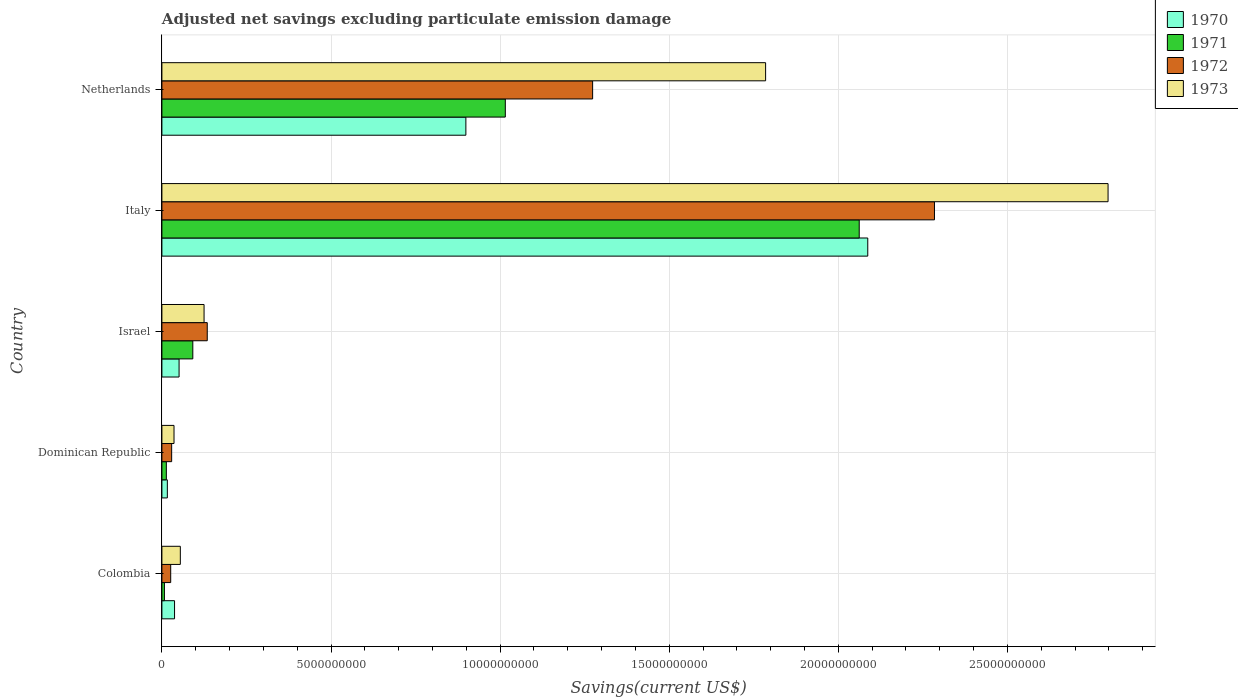How many different coloured bars are there?
Your response must be concise. 4. How many groups of bars are there?
Make the answer very short. 5. Are the number of bars on each tick of the Y-axis equal?
Ensure brevity in your answer.  Yes. How many bars are there on the 1st tick from the bottom?
Provide a short and direct response. 4. What is the label of the 4th group of bars from the top?
Your answer should be compact. Dominican Republic. In how many cases, is the number of bars for a given country not equal to the number of legend labels?
Offer a very short reply. 0. What is the adjusted net savings in 1970 in Dominican Republic?
Provide a succinct answer. 1.61e+08. Across all countries, what is the maximum adjusted net savings in 1971?
Ensure brevity in your answer.  2.06e+1. Across all countries, what is the minimum adjusted net savings in 1971?
Provide a short and direct response. 7.46e+07. In which country was the adjusted net savings in 1973 maximum?
Make the answer very short. Italy. In which country was the adjusted net savings in 1971 minimum?
Provide a succinct answer. Colombia. What is the total adjusted net savings in 1973 in the graph?
Give a very brief answer. 4.80e+1. What is the difference between the adjusted net savings in 1970 in Italy and that in Netherlands?
Make the answer very short. 1.19e+1. What is the difference between the adjusted net savings in 1973 in Italy and the adjusted net savings in 1970 in Colombia?
Offer a terse response. 2.76e+1. What is the average adjusted net savings in 1972 per country?
Offer a terse response. 7.49e+09. What is the difference between the adjusted net savings in 1970 and adjusted net savings in 1972 in Israel?
Your answer should be compact. -8.33e+08. In how many countries, is the adjusted net savings in 1971 greater than 25000000000 US$?
Provide a succinct answer. 0. What is the ratio of the adjusted net savings in 1972 in Israel to that in Italy?
Offer a terse response. 0.06. Is the adjusted net savings in 1972 in Dominican Republic less than that in Italy?
Keep it short and to the point. Yes. What is the difference between the highest and the second highest adjusted net savings in 1973?
Offer a terse response. 1.01e+1. What is the difference between the highest and the lowest adjusted net savings in 1973?
Ensure brevity in your answer.  2.76e+1. In how many countries, is the adjusted net savings in 1973 greater than the average adjusted net savings in 1973 taken over all countries?
Offer a very short reply. 2. Is the sum of the adjusted net savings in 1971 in Colombia and Dominican Republic greater than the maximum adjusted net savings in 1972 across all countries?
Offer a terse response. No. Is it the case that in every country, the sum of the adjusted net savings in 1972 and adjusted net savings in 1973 is greater than the sum of adjusted net savings in 1971 and adjusted net savings in 1970?
Ensure brevity in your answer.  No. What does the 1st bar from the top in Israel represents?
Your answer should be compact. 1973. What does the 4th bar from the bottom in Colombia represents?
Provide a short and direct response. 1973. Are all the bars in the graph horizontal?
Your answer should be very brief. Yes. Does the graph contain grids?
Provide a short and direct response. Yes. What is the title of the graph?
Provide a short and direct response. Adjusted net savings excluding particulate emission damage. What is the label or title of the X-axis?
Provide a succinct answer. Savings(current US$). What is the label or title of the Y-axis?
Ensure brevity in your answer.  Country. What is the Savings(current US$) of 1970 in Colombia?
Your response must be concise. 3.74e+08. What is the Savings(current US$) of 1971 in Colombia?
Offer a terse response. 7.46e+07. What is the Savings(current US$) in 1972 in Colombia?
Give a very brief answer. 2.60e+08. What is the Savings(current US$) of 1973 in Colombia?
Your answer should be very brief. 5.45e+08. What is the Savings(current US$) of 1970 in Dominican Republic?
Offer a terse response. 1.61e+08. What is the Savings(current US$) of 1971 in Dominican Republic?
Provide a succinct answer. 1.32e+08. What is the Savings(current US$) in 1972 in Dominican Republic?
Ensure brevity in your answer.  2.89e+08. What is the Savings(current US$) of 1973 in Dominican Republic?
Offer a very short reply. 3.58e+08. What is the Savings(current US$) of 1970 in Israel?
Offer a terse response. 5.08e+08. What is the Savings(current US$) in 1971 in Israel?
Your answer should be very brief. 9.14e+08. What is the Savings(current US$) of 1972 in Israel?
Your response must be concise. 1.34e+09. What is the Savings(current US$) of 1973 in Israel?
Provide a short and direct response. 1.25e+09. What is the Savings(current US$) in 1970 in Italy?
Your answer should be compact. 2.09e+1. What is the Savings(current US$) of 1971 in Italy?
Provide a short and direct response. 2.06e+1. What is the Savings(current US$) in 1972 in Italy?
Provide a short and direct response. 2.28e+1. What is the Savings(current US$) in 1973 in Italy?
Your answer should be very brief. 2.80e+1. What is the Savings(current US$) in 1970 in Netherlands?
Provide a short and direct response. 8.99e+09. What is the Savings(current US$) in 1971 in Netherlands?
Ensure brevity in your answer.  1.02e+1. What is the Savings(current US$) of 1972 in Netherlands?
Offer a terse response. 1.27e+1. What is the Savings(current US$) of 1973 in Netherlands?
Provide a succinct answer. 1.79e+1. Across all countries, what is the maximum Savings(current US$) of 1970?
Your answer should be compact. 2.09e+1. Across all countries, what is the maximum Savings(current US$) of 1971?
Provide a succinct answer. 2.06e+1. Across all countries, what is the maximum Savings(current US$) of 1972?
Make the answer very short. 2.28e+1. Across all countries, what is the maximum Savings(current US$) of 1973?
Your answer should be compact. 2.80e+1. Across all countries, what is the minimum Savings(current US$) in 1970?
Your answer should be very brief. 1.61e+08. Across all countries, what is the minimum Savings(current US$) of 1971?
Your response must be concise. 7.46e+07. Across all countries, what is the minimum Savings(current US$) in 1972?
Your answer should be very brief. 2.60e+08. Across all countries, what is the minimum Savings(current US$) in 1973?
Provide a short and direct response. 3.58e+08. What is the total Savings(current US$) of 1970 in the graph?
Give a very brief answer. 3.09e+1. What is the total Savings(current US$) of 1971 in the graph?
Provide a short and direct response. 3.19e+1. What is the total Savings(current US$) of 1972 in the graph?
Your answer should be compact. 3.75e+1. What is the total Savings(current US$) in 1973 in the graph?
Your answer should be very brief. 4.80e+1. What is the difference between the Savings(current US$) of 1970 in Colombia and that in Dominican Republic?
Provide a short and direct response. 2.13e+08. What is the difference between the Savings(current US$) in 1971 in Colombia and that in Dominican Republic?
Keep it short and to the point. -5.69e+07. What is the difference between the Savings(current US$) in 1972 in Colombia and that in Dominican Republic?
Your response must be concise. -2.84e+07. What is the difference between the Savings(current US$) in 1973 in Colombia and that in Dominican Republic?
Your answer should be very brief. 1.87e+08. What is the difference between the Savings(current US$) in 1970 in Colombia and that in Israel?
Ensure brevity in your answer.  -1.34e+08. What is the difference between the Savings(current US$) in 1971 in Colombia and that in Israel?
Offer a terse response. -8.40e+08. What is the difference between the Savings(current US$) of 1972 in Colombia and that in Israel?
Your answer should be compact. -1.08e+09. What is the difference between the Savings(current US$) in 1973 in Colombia and that in Israel?
Make the answer very short. -7.02e+08. What is the difference between the Savings(current US$) in 1970 in Colombia and that in Italy?
Your answer should be compact. -2.05e+1. What is the difference between the Savings(current US$) of 1971 in Colombia and that in Italy?
Your answer should be very brief. -2.05e+1. What is the difference between the Savings(current US$) in 1972 in Colombia and that in Italy?
Your response must be concise. -2.26e+1. What is the difference between the Savings(current US$) in 1973 in Colombia and that in Italy?
Offer a very short reply. -2.74e+1. What is the difference between the Savings(current US$) in 1970 in Colombia and that in Netherlands?
Offer a very short reply. -8.61e+09. What is the difference between the Savings(current US$) of 1971 in Colombia and that in Netherlands?
Make the answer very short. -1.01e+1. What is the difference between the Savings(current US$) of 1972 in Colombia and that in Netherlands?
Your answer should be compact. -1.25e+1. What is the difference between the Savings(current US$) of 1973 in Colombia and that in Netherlands?
Make the answer very short. -1.73e+1. What is the difference between the Savings(current US$) in 1970 in Dominican Republic and that in Israel?
Make the answer very short. -3.47e+08. What is the difference between the Savings(current US$) of 1971 in Dominican Republic and that in Israel?
Offer a very short reply. -7.83e+08. What is the difference between the Savings(current US$) in 1972 in Dominican Republic and that in Israel?
Give a very brief answer. -1.05e+09. What is the difference between the Savings(current US$) in 1973 in Dominican Republic and that in Israel?
Your answer should be very brief. -8.89e+08. What is the difference between the Savings(current US$) in 1970 in Dominican Republic and that in Italy?
Your response must be concise. -2.07e+1. What is the difference between the Savings(current US$) in 1971 in Dominican Republic and that in Italy?
Your answer should be compact. -2.05e+1. What is the difference between the Savings(current US$) of 1972 in Dominican Republic and that in Italy?
Offer a very short reply. -2.26e+1. What is the difference between the Savings(current US$) in 1973 in Dominican Republic and that in Italy?
Your response must be concise. -2.76e+1. What is the difference between the Savings(current US$) of 1970 in Dominican Republic and that in Netherlands?
Your answer should be very brief. -8.83e+09. What is the difference between the Savings(current US$) in 1971 in Dominican Republic and that in Netherlands?
Your response must be concise. -1.00e+1. What is the difference between the Savings(current US$) in 1972 in Dominican Republic and that in Netherlands?
Your answer should be compact. -1.24e+1. What is the difference between the Savings(current US$) of 1973 in Dominican Republic and that in Netherlands?
Provide a succinct answer. -1.75e+1. What is the difference between the Savings(current US$) in 1970 in Israel and that in Italy?
Provide a short and direct response. -2.04e+1. What is the difference between the Savings(current US$) in 1971 in Israel and that in Italy?
Your answer should be compact. -1.97e+1. What is the difference between the Savings(current US$) in 1972 in Israel and that in Italy?
Ensure brevity in your answer.  -2.15e+1. What is the difference between the Savings(current US$) of 1973 in Israel and that in Italy?
Your response must be concise. -2.67e+1. What is the difference between the Savings(current US$) of 1970 in Israel and that in Netherlands?
Give a very brief answer. -8.48e+09. What is the difference between the Savings(current US$) in 1971 in Israel and that in Netherlands?
Your response must be concise. -9.24e+09. What is the difference between the Savings(current US$) in 1972 in Israel and that in Netherlands?
Make the answer very short. -1.14e+1. What is the difference between the Savings(current US$) of 1973 in Israel and that in Netherlands?
Your response must be concise. -1.66e+1. What is the difference between the Savings(current US$) of 1970 in Italy and that in Netherlands?
Your answer should be compact. 1.19e+1. What is the difference between the Savings(current US$) of 1971 in Italy and that in Netherlands?
Your answer should be very brief. 1.05e+1. What is the difference between the Savings(current US$) of 1972 in Italy and that in Netherlands?
Your answer should be very brief. 1.01e+1. What is the difference between the Savings(current US$) of 1973 in Italy and that in Netherlands?
Ensure brevity in your answer.  1.01e+1. What is the difference between the Savings(current US$) of 1970 in Colombia and the Savings(current US$) of 1971 in Dominican Republic?
Your response must be concise. 2.42e+08. What is the difference between the Savings(current US$) of 1970 in Colombia and the Savings(current US$) of 1972 in Dominican Republic?
Provide a short and direct response. 8.52e+07. What is the difference between the Savings(current US$) in 1970 in Colombia and the Savings(current US$) in 1973 in Dominican Republic?
Provide a short and direct response. 1.57e+07. What is the difference between the Savings(current US$) of 1971 in Colombia and the Savings(current US$) of 1972 in Dominican Republic?
Your response must be concise. -2.14e+08. What is the difference between the Savings(current US$) in 1971 in Colombia and the Savings(current US$) in 1973 in Dominican Republic?
Your response must be concise. -2.84e+08. What is the difference between the Savings(current US$) in 1972 in Colombia and the Savings(current US$) in 1973 in Dominican Republic?
Provide a succinct answer. -9.79e+07. What is the difference between the Savings(current US$) of 1970 in Colombia and the Savings(current US$) of 1971 in Israel?
Ensure brevity in your answer.  -5.40e+08. What is the difference between the Savings(current US$) of 1970 in Colombia and the Savings(current US$) of 1972 in Israel?
Offer a terse response. -9.67e+08. What is the difference between the Savings(current US$) of 1970 in Colombia and the Savings(current US$) of 1973 in Israel?
Your answer should be very brief. -8.73e+08. What is the difference between the Savings(current US$) of 1971 in Colombia and the Savings(current US$) of 1972 in Israel?
Your answer should be compact. -1.27e+09. What is the difference between the Savings(current US$) in 1971 in Colombia and the Savings(current US$) in 1973 in Israel?
Keep it short and to the point. -1.17e+09. What is the difference between the Savings(current US$) of 1972 in Colombia and the Savings(current US$) of 1973 in Israel?
Your response must be concise. -9.87e+08. What is the difference between the Savings(current US$) in 1970 in Colombia and the Savings(current US$) in 1971 in Italy?
Offer a terse response. -2.02e+1. What is the difference between the Savings(current US$) of 1970 in Colombia and the Savings(current US$) of 1972 in Italy?
Provide a succinct answer. -2.25e+1. What is the difference between the Savings(current US$) of 1970 in Colombia and the Savings(current US$) of 1973 in Italy?
Make the answer very short. -2.76e+1. What is the difference between the Savings(current US$) of 1971 in Colombia and the Savings(current US$) of 1972 in Italy?
Your response must be concise. -2.28e+1. What is the difference between the Savings(current US$) in 1971 in Colombia and the Savings(current US$) in 1973 in Italy?
Make the answer very short. -2.79e+1. What is the difference between the Savings(current US$) in 1972 in Colombia and the Savings(current US$) in 1973 in Italy?
Offer a very short reply. -2.77e+1. What is the difference between the Savings(current US$) in 1970 in Colombia and the Savings(current US$) in 1971 in Netherlands?
Offer a terse response. -9.78e+09. What is the difference between the Savings(current US$) in 1970 in Colombia and the Savings(current US$) in 1972 in Netherlands?
Make the answer very short. -1.24e+1. What is the difference between the Savings(current US$) in 1970 in Colombia and the Savings(current US$) in 1973 in Netherlands?
Offer a terse response. -1.75e+1. What is the difference between the Savings(current US$) in 1971 in Colombia and the Savings(current US$) in 1972 in Netherlands?
Offer a terse response. -1.27e+1. What is the difference between the Savings(current US$) of 1971 in Colombia and the Savings(current US$) of 1973 in Netherlands?
Your response must be concise. -1.78e+1. What is the difference between the Savings(current US$) in 1972 in Colombia and the Savings(current US$) in 1973 in Netherlands?
Your answer should be very brief. -1.76e+1. What is the difference between the Savings(current US$) of 1970 in Dominican Republic and the Savings(current US$) of 1971 in Israel?
Your response must be concise. -7.53e+08. What is the difference between the Savings(current US$) of 1970 in Dominican Republic and the Savings(current US$) of 1972 in Israel?
Your answer should be very brief. -1.18e+09. What is the difference between the Savings(current US$) in 1970 in Dominican Republic and the Savings(current US$) in 1973 in Israel?
Your answer should be very brief. -1.09e+09. What is the difference between the Savings(current US$) of 1971 in Dominican Republic and the Savings(current US$) of 1972 in Israel?
Provide a short and direct response. -1.21e+09. What is the difference between the Savings(current US$) of 1971 in Dominican Republic and the Savings(current US$) of 1973 in Israel?
Give a very brief answer. -1.12e+09. What is the difference between the Savings(current US$) in 1972 in Dominican Republic and the Savings(current US$) in 1973 in Israel?
Your answer should be compact. -9.58e+08. What is the difference between the Savings(current US$) of 1970 in Dominican Republic and the Savings(current US$) of 1971 in Italy?
Provide a short and direct response. -2.05e+1. What is the difference between the Savings(current US$) in 1970 in Dominican Republic and the Savings(current US$) in 1972 in Italy?
Your answer should be very brief. -2.27e+1. What is the difference between the Savings(current US$) in 1970 in Dominican Republic and the Savings(current US$) in 1973 in Italy?
Your answer should be very brief. -2.78e+1. What is the difference between the Savings(current US$) in 1971 in Dominican Republic and the Savings(current US$) in 1972 in Italy?
Your answer should be compact. -2.27e+1. What is the difference between the Savings(current US$) of 1971 in Dominican Republic and the Savings(current US$) of 1973 in Italy?
Keep it short and to the point. -2.78e+1. What is the difference between the Savings(current US$) in 1972 in Dominican Republic and the Savings(current US$) in 1973 in Italy?
Provide a short and direct response. -2.77e+1. What is the difference between the Savings(current US$) of 1970 in Dominican Republic and the Savings(current US$) of 1971 in Netherlands?
Keep it short and to the point. -9.99e+09. What is the difference between the Savings(current US$) of 1970 in Dominican Republic and the Savings(current US$) of 1972 in Netherlands?
Offer a very short reply. -1.26e+1. What is the difference between the Savings(current US$) of 1970 in Dominican Republic and the Savings(current US$) of 1973 in Netherlands?
Provide a short and direct response. -1.77e+1. What is the difference between the Savings(current US$) of 1971 in Dominican Republic and the Savings(current US$) of 1972 in Netherlands?
Your response must be concise. -1.26e+1. What is the difference between the Savings(current US$) in 1971 in Dominican Republic and the Savings(current US$) in 1973 in Netherlands?
Provide a short and direct response. -1.77e+1. What is the difference between the Savings(current US$) of 1972 in Dominican Republic and the Savings(current US$) of 1973 in Netherlands?
Make the answer very short. -1.76e+1. What is the difference between the Savings(current US$) of 1970 in Israel and the Savings(current US$) of 1971 in Italy?
Provide a short and direct response. -2.01e+1. What is the difference between the Savings(current US$) of 1970 in Israel and the Savings(current US$) of 1972 in Italy?
Make the answer very short. -2.23e+1. What is the difference between the Savings(current US$) of 1970 in Israel and the Savings(current US$) of 1973 in Italy?
Your answer should be compact. -2.75e+1. What is the difference between the Savings(current US$) in 1971 in Israel and the Savings(current US$) in 1972 in Italy?
Keep it short and to the point. -2.19e+1. What is the difference between the Savings(current US$) of 1971 in Israel and the Savings(current US$) of 1973 in Italy?
Keep it short and to the point. -2.71e+1. What is the difference between the Savings(current US$) in 1972 in Israel and the Savings(current US$) in 1973 in Italy?
Your answer should be very brief. -2.66e+1. What is the difference between the Savings(current US$) of 1970 in Israel and the Savings(current US$) of 1971 in Netherlands?
Offer a terse response. -9.65e+09. What is the difference between the Savings(current US$) of 1970 in Israel and the Savings(current US$) of 1972 in Netherlands?
Provide a succinct answer. -1.22e+1. What is the difference between the Savings(current US$) of 1970 in Israel and the Savings(current US$) of 1973 in Netherlands?
Offer a terse response. -1.73e+1. What is the difference between the Savings(current US$) of 1971 in Israel and the Savings(current US$) of 1972 in Netherlands?
Make the answer very short. -1.18e+1. What is the difference between the Savings(current US$) in 1971 in Israel and the Savings(current US$) in 1973 in Netherlands?
Offer a terse response. -1.69e+1. What is the difference between the Savings(current US$) of 1972 in Israel and the Savings(current US$) of 1973 in Netherlands?
Provide a succinct answer. -1.65e+1. What is the difference between the Savings(current US$) in 1970 in Italy and the Savings(current US$) in 1971 in Netherlands?
Keep it short and to the point. 1.07e+1. What is the difference between the Savings(current US$) in 1970 in Italy and the Savings(current US$) in 1972 in Netherlands?
Your response must be concise. 8.14e+09. What is the difference between the Savings(current US$) of 1970 in Italy and the Savings(current US$) of 1973 in Netherlands?
Ensure brevity in your answer.  3.02e+09. What is the difference between the Savings(current US$) of 1971 in Italy and the Savings(current US$) of 1972 in Netherlands?
Your answer should be compact. 7.88e+09. What is the difference between the Savings(current US$) of 1971 in Italy and the Savings(current US$) of 1973 in Netherlands?
Your answer should be compact. 2.77e+09. What is the difference between the Savings(current US$) of 1972 in Italy and the Savings(current US$) of 1973 in Netherlands?
Keep it short and to the point. 4.99e+09. What is the average Savings(current US$) in 1970 per country?
Ensure brevity in your answer.  6.18e+09. What is the average Savings(current US$) in 1971 per country?
Provide a short and direct response. 6.38e+09. What is the average Savings(current US$) of 1972 per country?
Offer a terse response. 7.49e+09. What is the average Savings(current US$) in 1973 per country?
Ensure brevity in your answer.  9.60e+09. What is the difference between the Savings(current US$) of 1970 and Savings(current US$) of 1971 in Colombia?
Ensure brevity in your answer.  2.99e+08. What is the difference between the Savings(current US$) of 1970 and Savings(current US$) of 1972 in Colombia?
Your answer should be very brief. 1.14e+08. What is the difference between the Savings(current US$) of 1970 and Savings(current US$) of 1973 in Colombia?
Your answer should be very brief. -1.71e+08. What is the difference between the Savings(current US$) of 1971 and Savings(current US$) of 1972 in Colombia?
Your answer should be very brief. -1.86e+08. What is the difference between the Savings(current US$) of 1971 and Savings(current US$) of 1973 in Colombia?
Provide a short and direct response. -4.70e+08. What is the difference between the Savings(current US$) of 1972 and Savings(current US$) of 1973 in Colombia?
Give a very brief answer. -2.85e+08. What is the difference between the Savings(current US$) of 1970 and Savings(current US$) of 1971 in Dominican Republic?
Keep it short and to the point. 2.96e+07. What is the difference between the Savings(current US$) of 1970 and Savings(current US$) of 1972 in Dominican Republic?
Keep it short and to the point. -1.28e+08. What is the difference between the Savings(current US$) of 1970 and Savings(current US$) of 1973 in Dominican Republic?
Give a very brief answer. -1.97e+08. What is the difference between the Savings(current US$) of 1971 and Savings(current US$) of 1972 in Dominican Republic?
Give a very brief answer. -1.57e+08. What is the difference between the Savings(current US$) in 1971 and Savings(current US$) in 1973 in Dominican Republic?
Offer a very short reply. -2.27e+08. What is the difference between the Savings(current US$) of 1972 and Savings(current US$) of 1973 in Dominican Republic?
Ensure brevity in your answer.  -6.95e+07. What is the difference between the Savings(current US$) of 1970 and Savings(current US$) of 1971 in Israel?
Keep it short and to the point. -4.06e+08. What is the difference between the Savings(current US$) of 1970 and Savings(current US$) of 1972 in Israel?
Make the answer very short. -8.33e+08. What is the difference between the Savings(current US$) of 1970 and Savings(current US$) of 1973 in Israel?
Your answer should be compact. -7.39e+08. What is the difference between the Savings(current US$) in 1971 and Savings(current US$) in 1972 in Israel?
Offer a very short reply. -4.27e+08. What is the difference between the Savings(current US$) of 1971 and Savings(current US$) of 1973 in Israel?
Your answer should be very brief. -3.33e+08. What is the difference between the Savings(current US$) of 1972 and Savings(current US$) of 1973 in Israel?
Your answer should be compact. 9.40e+07. What is the difference between the Savings(current US$) of 1970 and Savings(current US$) of 1971 in Italy?
Offer a very short reply. 2.53e+08. What is the difference between the Savings(current US$) in 1970 and Savings(current US$) in 1972 in Italy?
Provide a succinct answer. -1.97e+09. What is the difference between the Savings(current US$) in 1970 and Savings(current US$) in 1973 in Italy?
Offer a very short reply. -7.11e+09. What is the difference between the Savings(current US$) in 1971 and Savings(current US$) in 1972 in Italy?
Provide a short and direct response. -2.23e+09. What is the difference between the Savings(current US$) in 1971 and Savings(current US$) in 1973 in Italy?
Keep it short and to the point. -7.36e+09. What is the difference between the Savings(current US$) of 1972 and Savings(current US$) of 1973 in Italy?
Make the answer very short. -5.13e+09. What is the difference between the Savings(current US$) of 1970 and Savings(current US$) of 1971 in Netherlands?
Provide a succinct answer. -1.17e+09. What is the difference between the Savings(current US$) in 1970 and Savings(current US$) in 1972 in Netherlands?
Ensure brevity in your answer.  -3.75e+09. What is the difference between the Savings(current US$) of 1970 and Savings(current US$) of 1973 in Netherlands?
Your response must be concise. -8.86e+09. What is the difference between the Savings(current US$) of 1971 and Savings(current US$) of 1972 in Netherlands?
Ensure brevity in your answer.  -2.58e+09. What is the difference between the Savings(current US$) in 1971 and Savings(current US$) in 1973 in Netherlands?
Your answer should be compact. -7.70e+09. What is the difference between the Savings(current US$) in 1972 and Savings(current US$) in 1973 in Netherlands?
Keep it short and to the point. -5.11e+09. What is the ratio of the Savings(current US$) in 1970 in Colombia to that in Dominican Republic?
Ensure brevity in your answer.  2.32. What is the ratio of the Savings(current US$) of 1971 in Colombia to that in Dominican Republic?
Give a very brief answer. 0.57. What is the ratio of the Savings(current US$) in 1972 in Colombia to that in Dominican Republic?
Offer a very short reply. 0.9. What is the ratio of the Savings(current US$) in 1973 in Colombia to that in Dominican Republic?
Ensure brevity in your answer.  1.52. What is the ratio of the Savings(current US$) in 1970 in Colombia to that in Israel?
Your answer should be very brief. 0.74. What is the ratio of the Savings(current US$) in 1971 in Colombia to that in Israel?
Give a very brief answer. 0.08. What is the ratio of the Savings(current US$) in 1972 in Colombia to that in Israel?
Your answer should be very brief. 0.19. What is the ratio of the Savings(current US$) in 1973 in Colombia to that in Israel?
Ensure brevity in your answer.  0.44. What is the ratio of the Savings(current US$) of 1970 in Colombia to that in Italy?
Keep it short and to the point. 0.02. What is the ratio of the Savings(current US$) of 1971 in Colombia to that in Italy?
Your response must be concise. 0. What is the ratio of the Savings(current US$) of 1972 in Colombia to that in Italy?
Offer a terse response. 0.01. What is the ratio of the Savings(current US$) in 1973 in Colombia to that in Italy?
Your answer should be compact. 0.02. What is the ratio of the Savings(current US$) of 1970 in Colombia to that in Netherlands?
Your response must be concise. 0.04. What is the ratio of the Savings(current US$) in 1971 in Colombia to that in Netherlands?
Your response must be concise. 0.01. What is the ratio of the Savings(current US$) in 1972 in Colombia to that in Netherlands?
Ensure brevity in your answer.  0.02. What is the ratio of the Savings(current US$) in 1973 in Colombia to that in Netherlands?
Your response must be concise. 0.03. What is the ratio of the Savings(current US$) in 1970 in Dominican Republic to that in Israel?
Offer a very short reply. 0.32. What is the ratio of the Savings(current US$) in 1971 in Dominican Republic to that in Israel?
Make the answer very short. 0.14. What is the ratio of the Savings(current US$) of 1972 in Dominican Republic to that in Israel?
Keep it short and to the point. 0.22. What is the ratio of the Savings(current US$) in 1973 in Dominican Republic to that in Israel?
Give a very brief answer. 0.29. What is the ratio of the Savings(current US$) of 1970 in Dominican Republic to that in Italy?
Give a very brief answer. 0.01. What is the ratio of the Savings(current US$) of 1971 in Dominican Republic to that in Italy?
Keep it short and to the point. 0.01. What is the ratio of the Savings(current US$) in 1972 in Dominican Republic to that in Italy?
Offer a very short reply. 0.01. What is the ratio of the Savings(current US$) of 1973 in Dominican Republic to that in Italy?
Your response must be concise. 0.01. What is the ratio of the Savings(current US$) in 1970 in Dominican Republic to that in Netherlands?
Your answer should be compact. 0.02. What is the ratio of the Savings(current US$) in 1971 in Dominican Republic to that in Netherlands?
Provide a short and direct response. 0.01. What is the ratio of the Savings(current US$) in 1972 in Dominican Republic to that in Netherlands?
Your answer should be very brief. 0.02. What is the ratio of the Savings(current US$) in 1973 in Dominican Republic to that in Netherlands?
Give a very brief answer. 0.02. What is the ratio of the Savings(current US$) in 1970 in Israel to that in Italy?
Give a very brief answer. 0.02. What is the ratio of the Savings(current US$) of 1971 in Israel to that in Italy?
Give a very brief answer. 0.04. What is the ratio of the Savings(current US$) in 1972 in Israel to that in Italy?
Your answer should be very brief. 0.06. What is the ratio of the Savings(current US$) of 1973 in Israel to that in Italy?
Your answer should be very brief. 0.04. What is the ratio of the Savings(current US$) in 1970 in Israel to that in Netherlands?
Offer a very short reply. 0.06. What is the ratio of the Savings(current US$) of 1971 in Israel to that in Netherlands?
Your response must be concise. 0.09. What is the ratio of the Savings(current US$) in 1972 in Israel to that in Netherlands?
Provide a succinct answer. 0.11. What is the ratio of the Savings(current US$) of 1973 in Israel to that in Netherlands?
Offer a terse response. 0.07. What is the ratio of the Savings(current US$) in 1970 in Italy to that in Netherlands?
Give a very brief answer. 2.32. What is the ratio of the Savings(current US$) of 1971 in Italy to that in Netherlands?
Give a very brief answer. 2.03. What is the ratio of the Savings(current US$) in 1972 in Italy to that in Netherlands?
Ensure brevity in your answer.  1.79. What is the ratio of the Savings(current US$) in 1973 in Italy to that in Netherlands?
Provide a short and direct response. 1.57. What is the difference between the highest and the second highest Savings(current US$) of 1970?
Make the answer very short. 1.19e+1. What is the difference between the highest and the second highest Savings(current US$) of 1971?
Give a very brief answer. 1.05e+1. What is the difference between the highest and the second highest Savings(current US$) in 1972?
Offer a terse response. 1.01e+1. What is the difference between the highest and the second highest Savings(current US$) in 1973?
Your answer should be very brief. 1.01e+1. What is the difference between the highest and the lowest Savings(current US$) in 1970?
Your response must be concise. 2.07e+1. What is the difference between the highest and the lowest Savings(current US$) in 1971?
Make the answer very short. 2.05e+1. What is the difference between the highest and the lowest Savings(current US$) of 1972?
Ensure brevity in your answer.  2.26e+1. What is the difference between the highest and the lowest Savings(current US$) in 1973?
Make the answer very short. 2.76e+1. 